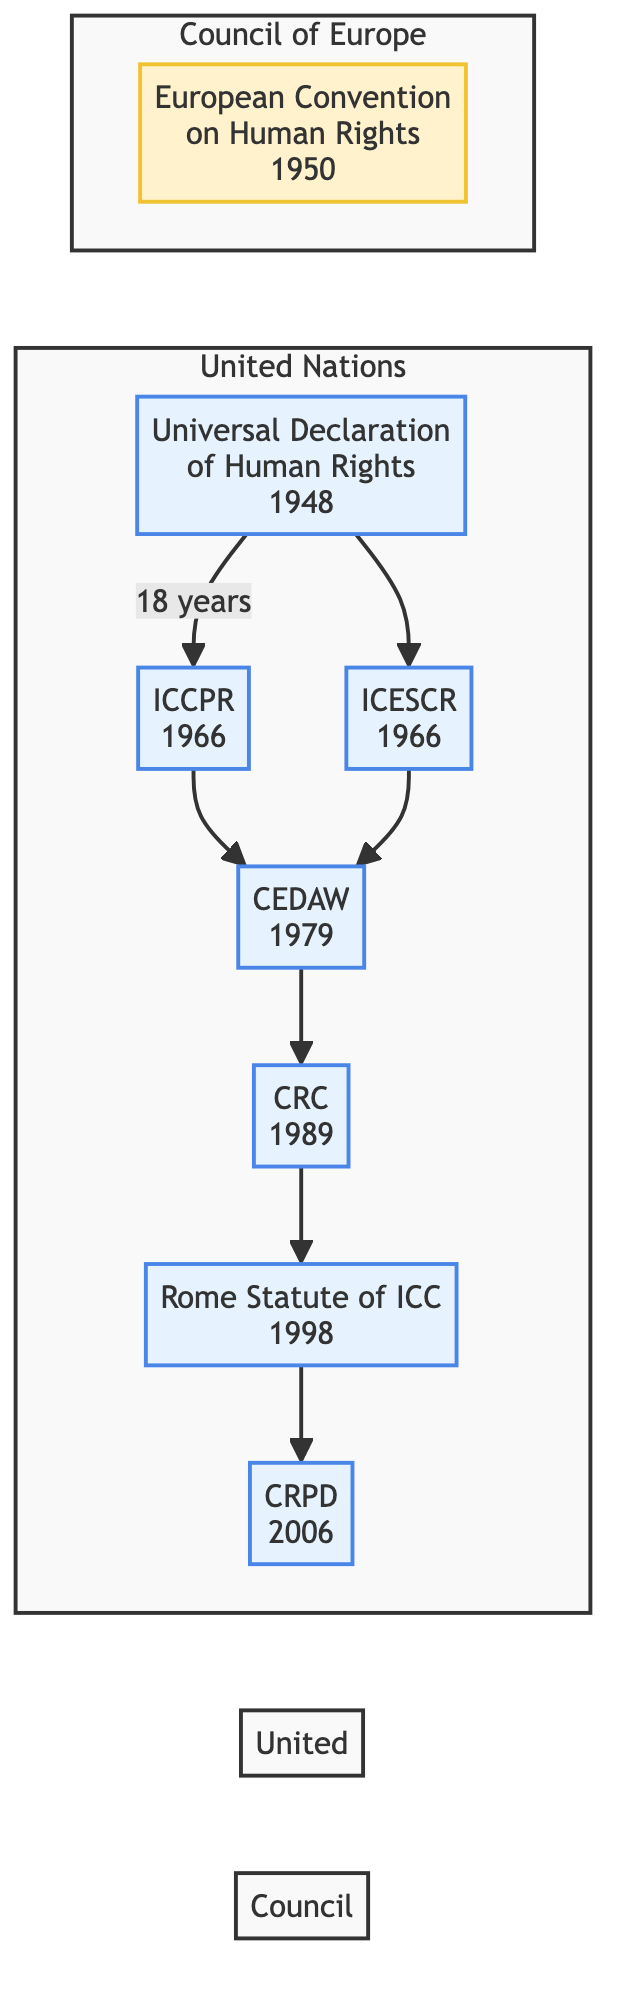What year was the Universal Declaration of Human Rights adopted? According to the diagram, the Universal Declaration of Human Rights is marked with the year 1948. This value is directly stated in the node representing the Universal Declaration.
Answer: 1948 How many treaties are listed in the diagram? The diagram contains seven treaties, as represented by the nodes connected in the flowchart. Counting each of the treaty nodes confirms that there are a total of 7.
Answer: 7 Which treaty follows the International Covenant on Civil and Political Rights? In the flowchart, the International Covenant on Civil and Political Rights is denoted as ICCPR, which has connections leading to CEDAW (Convention on the Elimination of All Forms of Discrimination Against Women). Therefore, CEDAW is the next treaty in the flowchart after ICCPR.
Answer: CEDAW What is the organization behind the Convention on the Rights of Persons with Disabilities? The flowchart indicates that the Convention on the Rights of Persons with Disabilities is created under the United Nations, which can be inferred from its classification and the surrounding nodes signifying UN treaties.
Answer: United Nations Which treaty was established in the year after the Convention on the Rights of the Child? Following the Convention on the Rights of the Child (1989), the next treaty in the flowchart is the Rome Statute of the International Criminal Court, which was established in 1998. The flowchart indicates a direct connection from CRC to this treaty.
Answer: Rome Statute of the International Criminal Court How many treaties were established during the 1960s? The flowchart shows two treaties established during the 1960s: the International Covenant on Civil and Political Rights (ICCPR) in 1966 and the International Covenant on Economic, Social and Cultural Rights (ICESCR), which is also from 1966. Thus, the count of treaties from this decade is 2.
Answer: 2 What is the first treaty that comes after the European Convention on Human Rights? The European Convention on Human Rights is a distinct node in the diagram and does not directly connect to any other treaties. Therefore, there is no treaty that immediately follows it in the flowchart. Thus the answer is none or no subsequent treaty.
Answer: None Which organizations are represented in the diagram? The diagram features two organizations: the United Nations, represented by most of the treaties, and the Council of Europe, represented specifically by the European Convention on Human Rights. This is noted by the grouping of nodes under different colored classifications.
Answer: United Nations, Council of Europe What is the last treaty in the flowchart? The flowchart indicates that the last treaty connected in the sequence is the Convention on the Rights of Persons with Disabilities (CRPD), which is the final node after the Rome Statute.
Answer: Convention on the Rights of Persons with Disabilities 